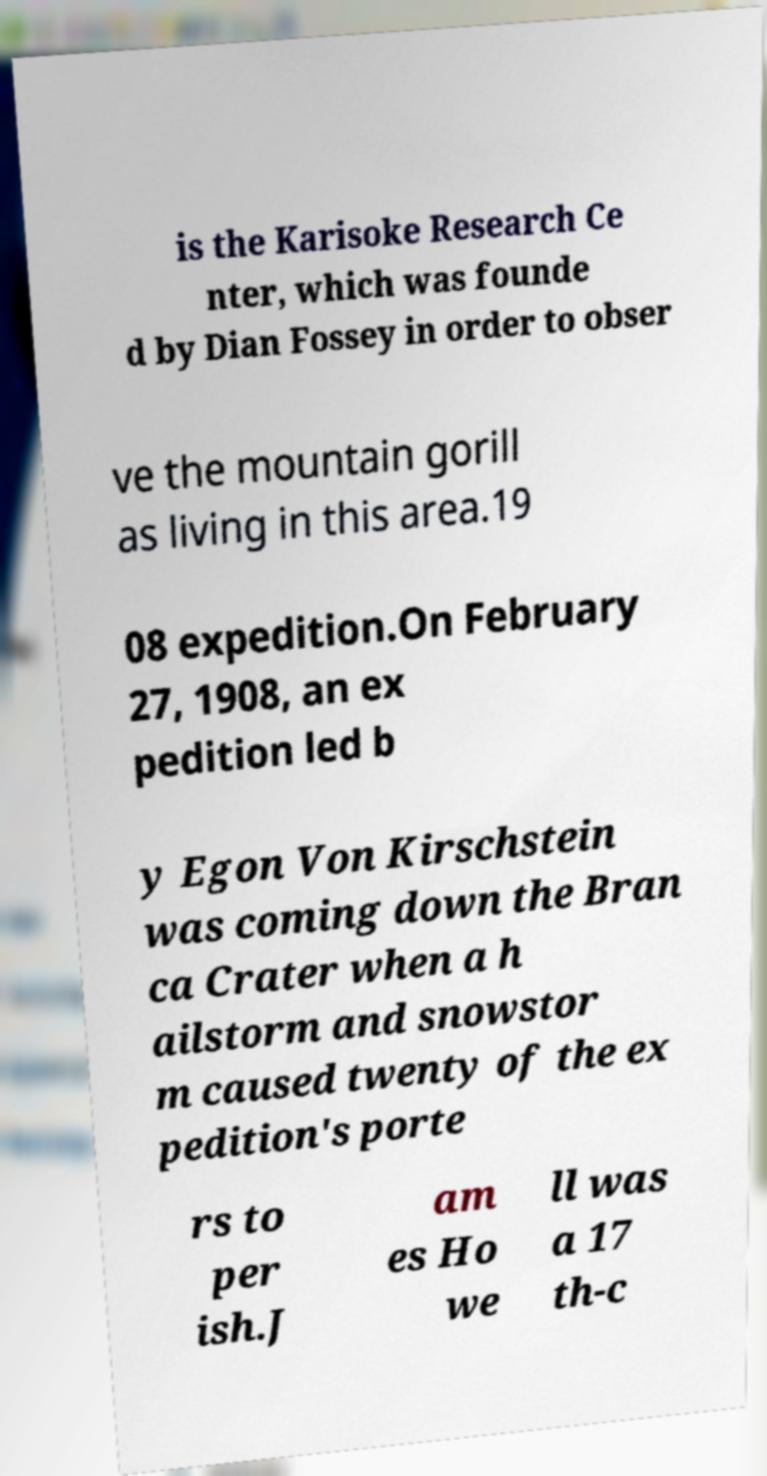There's text embedded in this image that I need extracted. Can you transcribe it verbatim? is the Karisoke Research Ce nter, which was founde d by Dian Fossey in order to obser ve the mountain gorill as living in this area.19 08 expedition.On February 27, 1908, an ex pedition led b y Egon Von Kirschstein was coming down the Bran ca Crater when a h ailstorm and snowstor m caused twenty of the ex pedition's porte rs to per ish.J am es Ho we ll was a 17 th-c 